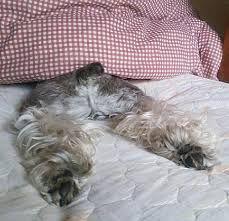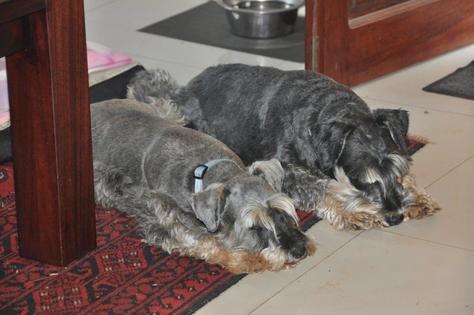The first image is the image on the left, the second image is the image on the right. Evaluate the accuracy of this statement regarding the images: "The left image shows a schnauzer with its rear to the camera, lying on its belly on a pillow, with its legs extended behind it and its head turned to the right.". Is it true? Answer yes or no. No. The first image is the image on the left, the second image is the image on the right. Given the left and right images, does the statement "All the dogs are laying on their stomachs." hold true? Answer yes or no. Yes. 